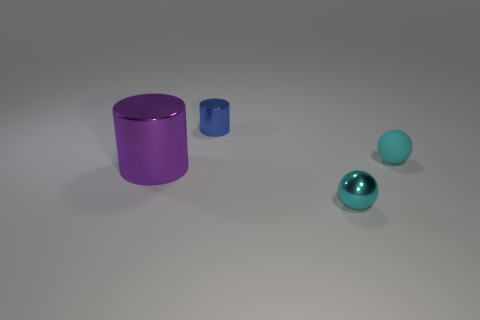Add 4 tiny cyan matte spheres. How many objects exist? 8 Subtract all tiny blue shiny cylinders. Subtract all large rubber objects. How many objects are left? 3 Add 3 blue metallic objects. How many blue metallic objects are left? 4 Add 1 small cylinders. How many small cylinders exist? 2 Subtract 0 blue blocks. How many objects are left? 4 